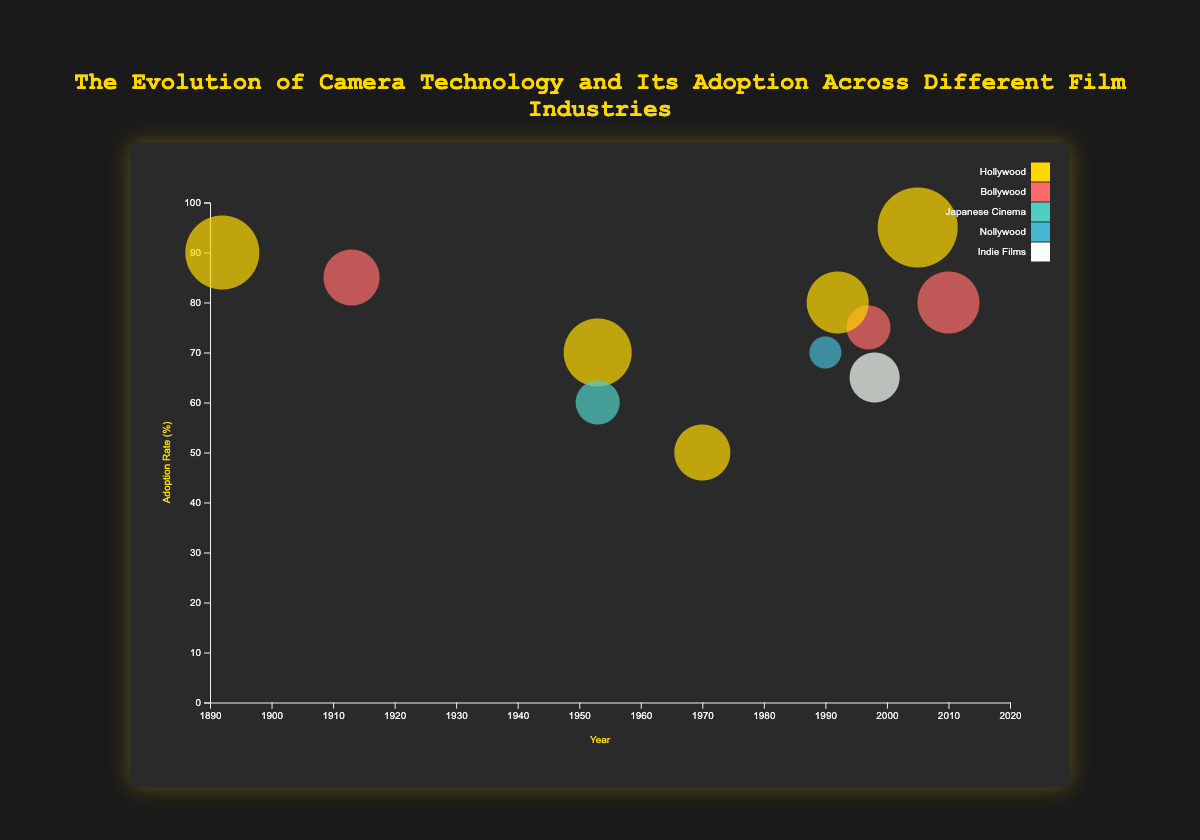What is the adoption rate of Digital Cinema in Bollywood? Look for Bollywood data points and find the one with "Digital Cinema" technology. The adoption rate is 80%.
Answer: 80% Which industry had the highest adoption rate for Digital Cinema technology? Compare adoption rates for Digital Cinema across different industries. Hollywood has the highest with 95%.
Answer: Hollywood In which year did Hollywood adopt Digital Sound technology? Find the Hollywood data point with "Digital Sound" technology. The year is 1992.
Answer: 1992 How does the adoption rate of 35mm Film in Hollywood compare to that in Bollywood? Look for 35mm Film in Hollywood and Bollywood. Hollywood has a 90% adoption rate while Bollywood has 85%. Hollywood's rate is higher.
Answer: Hollywood’s rate is higher Which technology has the highest impact score overall? Check impact scores across all technologies. Digital Cinema in Hollywood has the highest impact score of 100.
Answer: Digital Cinema What is the average adoption rate of Digital Sound technology across all industries? Find adoption rates for Digital Sound in all industries (80 and 75). The average is (80 + 75) / 2 = 77.5%.
Answer: 77.5% Which industry adopted HD Video technology, and what was the adoption rate? Find the data point with "HD Video" technology. Indie Films adopted it with a 65% adoption rate.
Answer: Indie Films, 65% Compare the adoption rate and impact score of IMAX technology in Hollywood to that of Video technology in Nollywood. Find the Hollywood IMAX and Nollywood Video data points. IMAX has an adoption rate of 50% and impact score of 80, while Video has 70% adoption rate and 60 impact score.
Answer: IMAX: 50% adoption, 80 impact; Video: 70% adoption, 60 impact How many unique technologies are visualized in the dataset? Count distinct "technology" values in the dataset. There are 7 unique technologies: 35mm Film, CinemaScope, Television, Digital Cinema, Video, IMAX, Digital Sound, HD Video.
Answer: 8 What is the adoption rate of Television technology in Japanese Cinema? Find Japanese Cinema data point with "Television" technology. The adoption rate is 60%.
Answer: 60% 